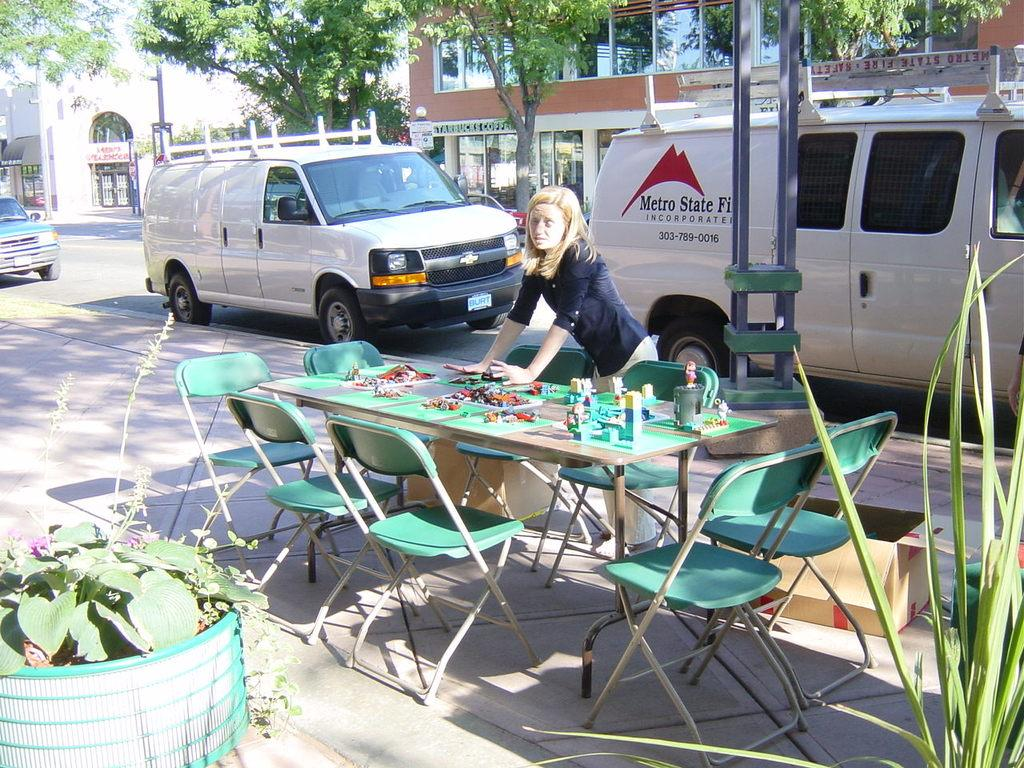<image>
Relay a brief, clear account of the picture shown. The white van on the road is Metro State. 